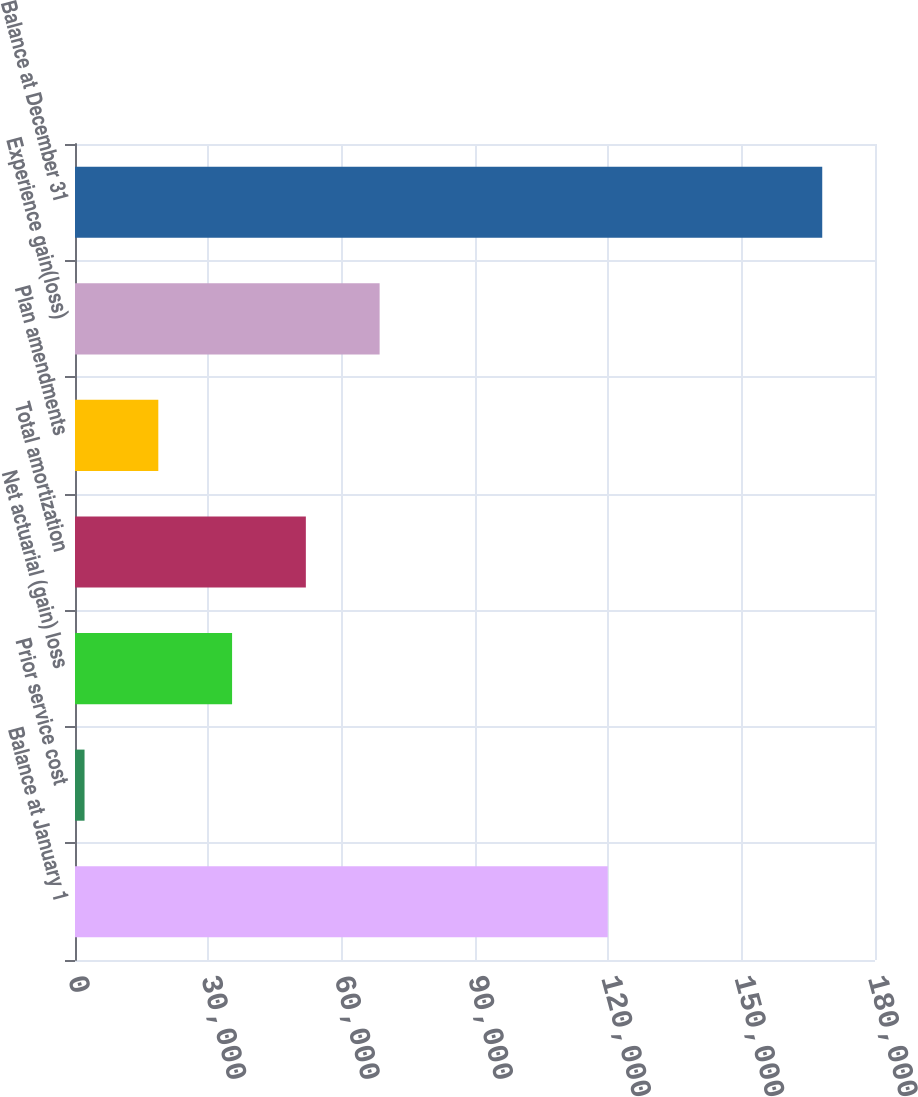<chart> <loc_0><loc_0><loc_500><loc_500><bar_chart><fcel>Balance at January 1<fcel>Prior service cost<fcel>Net actuarial (gain) loss<fcel>Total amortization<fcel>Plan amendments<fcel>Experience gain(loss)<fcel>Balance at December 31<nl><fcel>119863<fcel>2146<fcel>35342.6<fcel>51940.9<fcel>18744.3<fcel>68539.2<fcel>168129<nl></chart> 